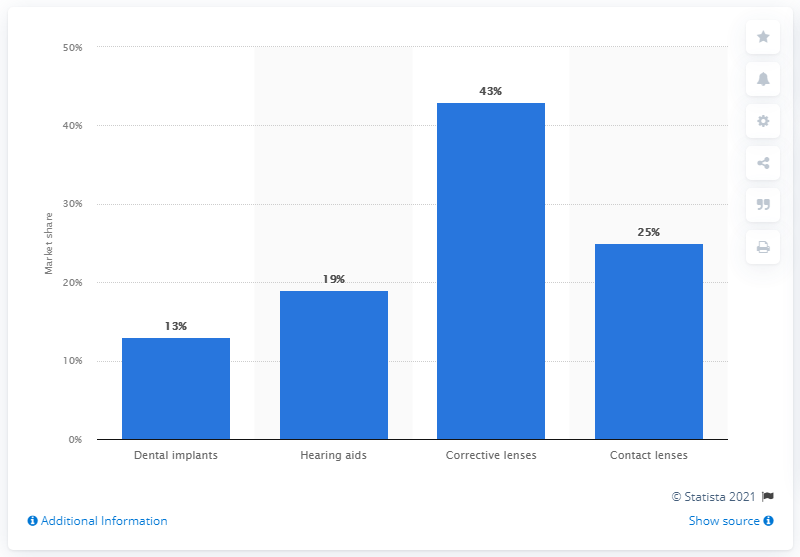Draw attention to some important aspects in this diagram. In 2019, contact lenses accounted for one fourth of the global major consumer medical devices market. 